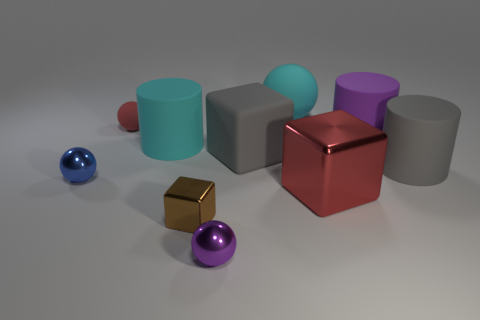Subtract all small cubes. How many cubes are left? 2 Subtract all brown blocks. How many blocks are left? 2 Subtract 3 spheres. How many spheres are left? 1 Add 8 tiny brown metallic cubes. How many tiny brown metallic cubes are left? 9 Add 5 large matte cylinders. How many large matte cylinders exist? 8 Subtract 1 brown cubes. How many objects are left? 9 Subtract all cylinders. How many objects are left? 7 Subtract all gray balls. Subtract all green blocks. How many balls are left? 4 Subtract all purple blocks. How many brown cylinders are left? 0 Subtract all tiny yellow cubes. Subtract all small red matte spheres. How many objects are left? 9 